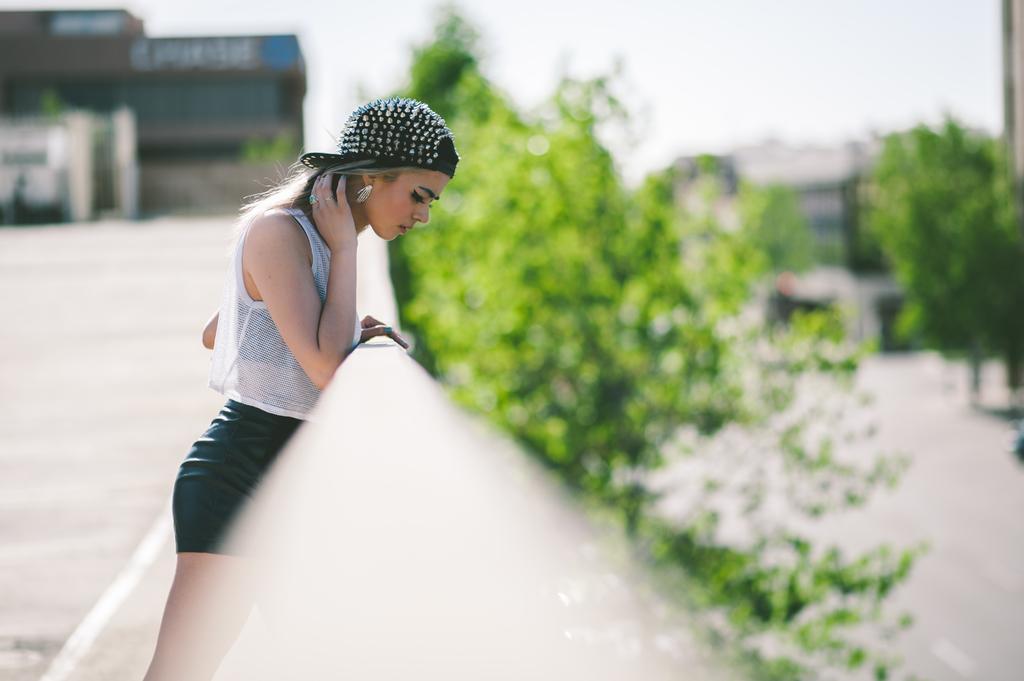Could you give a brief overview of what you see in this image? In this image we can see a person. There are few buildings in the image. There are many trees in the image. There is a blur background in the image. 